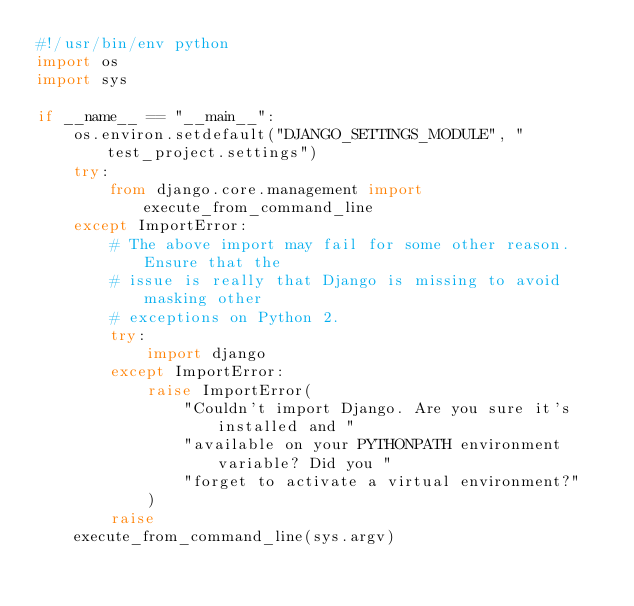Convert code to text. <code><loc_0><loc_0><loc_500><loc_500><_Python_>#!/usr/bin/env python
import os
import sys

if __name__ == "__main__":
    os.environ.setdefault("DJANGO_SETTINGS_MODULE", "test_project.settings")
    try:
        from django.core.management import execute_from_command_line
    except ImportError:
        # The above import may fail for some other reason. Ensure that the
        # issue is really that Django is missing to avoid masking other
        # exceptions on Python 2.
        try:
            import django
        except ImportError:
            raise ImportError(
                "Couldn't import Django. Are you sure it's installed and "
                "available on your PYTHONPATH environment variable? Did you "
                "forget to activate a virtual environment?"
            )
        raise
    execute_from_command_line(sys.argv)
</code> 